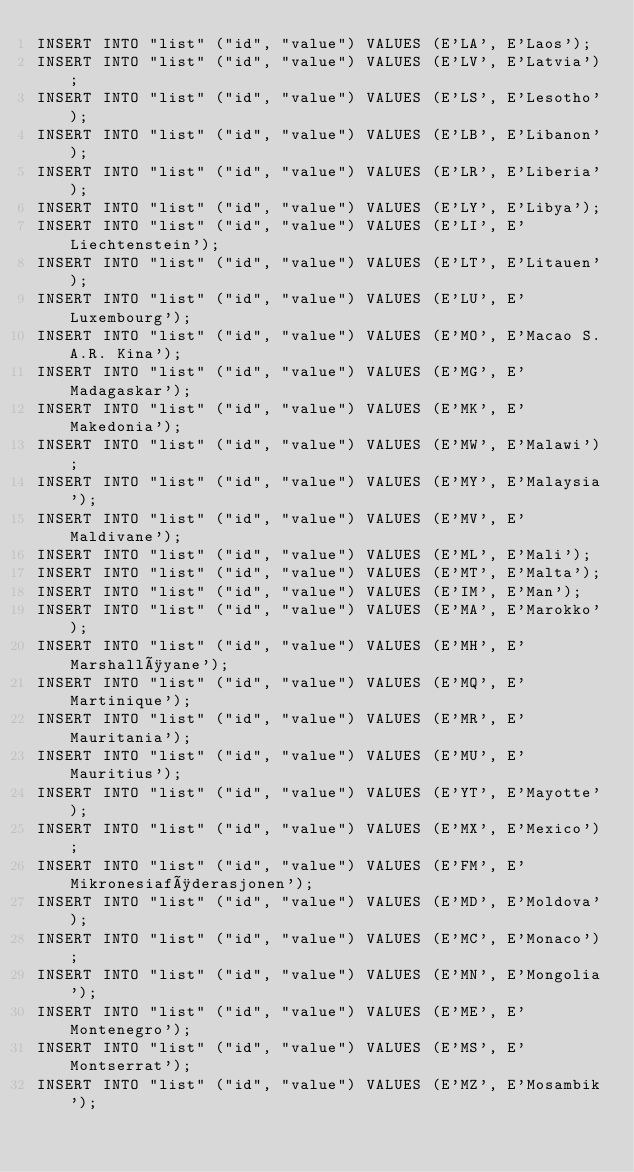Convert code to text. <code><loc_0><loc_0><loc_500><loc_500><_SQL_>INSERT INTO "list" ("id", "value") VALUES (E'LA', E'Laos');
INSERT INTO "list" ("id", "value") VALUES (E'LV', E'Latvia');
INSERT INTO "list" ("id", "value") VALUES (E'LS', E'Lesotho');
INSERT INTO "list" ("id", "value") VALUES (E'LB', E'Libanon');
INSERT INTO "list" ("id", "value") VALUES (E'LR', E'Liberia');
INSERT INTO "list" ("id", "value") VALUES (E'LY', E'Libya');
INSERT INTO "list" ("id", "value") VALUES (E'LI', E'Liechtenstein');
INSERT INTO "list" ("id", "value") VALUES (E'LT', E'Litauen');
INSERT INTO "list" ("id", "value") VALUES (E'LU', E'Luxembourg');
INSERT INTO "list" ("id", "value") VALUES (E'MO', E'Macao S.A.R. Kina');
INSERT INTO "list" ("id", "value") VALUES (E'MG', E'Madagaskar');
INSERT INTO "list" ("id", "value") VALUES (E'MK', E'Makedonia');
INSERT INTO "list" ("id", "value") VALUES (E'MW', E'Malawi');
INSERT INTO "list" ("id", "value") VALUES (E'MY', E'Malaysia');
INSERT INTO "list" ("id", "value") VALUES (E'MV', E'Maldivane');
INSERT INTO "list" ("id", "value") VALUES (E'ML', E'Mali');
INSERT INTO "list" ("id", "value") VALUES (E'MT', E'Malta');
INSERT INTO "list" ("id", "value") VALUES (E'IM', E'Man');
INSERT INTO "list" ("id", "value") VALUES (E'MA', E'Marokko');
INSERT INTO "list" ("id", "value") VALUES (E'MH', E'Marshalløyane');
INSERT INTO "list" ("id", "value") VALUES (E'MQ', E'Martinique');
INSERT INTO "list" ("id", "value") VALUES (E'MR', E'Mauritania');
INSERT INTO "list" ("id", "value") VALUES (E'MU', E'Mauritius');
INSERT INTO "list" ("id", "value") VALUES (E'YT', E'Mayotte');
INSERT INTO "list" ("id", "value") VALUES (E'MX', E'Mexico');
INSERT INTO "list" ("id", "value") VALUES (E'FM', E'Mikronesiaføderasjonen');
INSERT INTO "list" ("id", "value") VALUES (E'MD', E'Moldova');
INSERT INTO "list" ("id", "value") VALUES (E'MC', E'Monaco');
INSERT INTO "list" ("id", "value") VALUES (E'MN', E'Mongolia');
INSERT INTO "list" ("id", "value") VALUES (E'ME', E'Montenegro');
INSERT INTO "list" ("id", "value") VALUES (E'MS', E'Montserrat');
INSERT INTO "list" ("id", "value") VALUES (E'MZ', E'Mosambik');</code> 